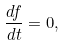<formula> <loc_0><loc_0><loc_500><loc_500>\frac { d f } { d t } = 0 ,</formula> 